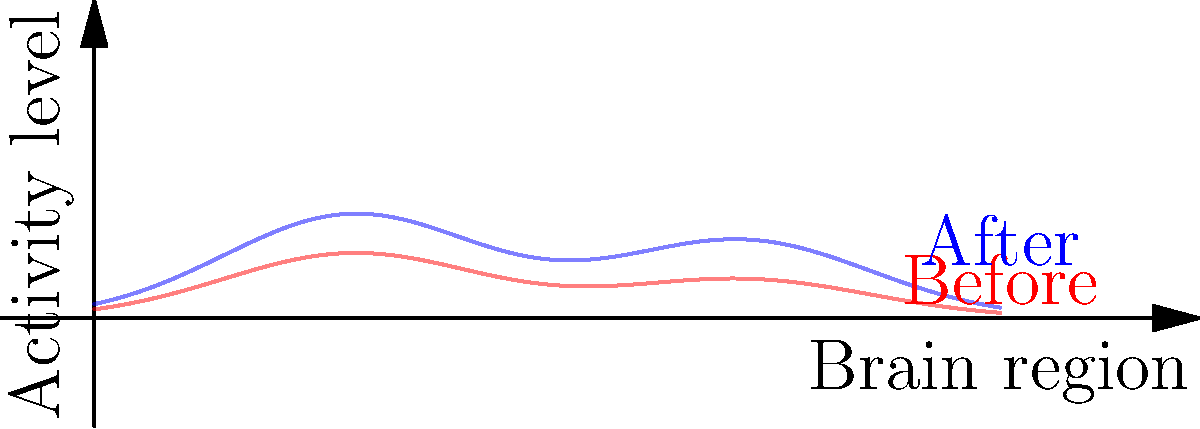Based on the heat map representation of brain activity patterns before and after a cognitive enhancement intervention, what potential concern might a neurologist raise regarding the observed changes? To answer this question, let's analyze the heat map step-by-step:

1. The red curve represents brain activity before the cognitive enhancement intervention, while the blue curve represents activity after the intervention.

2. We can observe that the blue curve shows higher peaks and overall increased activity compared to the red curve across all brain regions.

3. The increase in activity is not uniform:
   a. The first peak (around x=2) shows a more substantial increase.
   b. The second peak (around x=5) also increases but to a lesser extent.

4. From a neurologist's perspective, especially one who questions the safety and efficacy of cognitive enhancement methods, several concerns might arise:

   a. Overactivation: The significant increase in brain activity might lead to overactivation of certain brain regions, potentially causing neurological side effects or exhaustion.
   
   b. Imbalance: The non-uniform increase in activity across different brain regions might disrupt the brain's natural balance, potentially affecting other cognitive functions not intended to be enhanced.
   
   c. Long-term effects: Without substantial scientific evidence, it's unclear how this increased activity might affect the brain over time. There could be concerns about neural plasticity, neurotransmitter depletion, or even potential damage from prolonged overactivation.
   
   d. Lack of specificity: The enhancement appears to affect multiple brain regions, which might indicate a lack of specificity in the intervention. This could lead to unintended cognitive or behavioral changes.

5. Given the persona of a neurologist who questions the safety and efficacy of cognitive enhancement methods without substantial scientific evidence, the most pressing concern would likely be the potential for overactivation and its unknown long-term consequences.
Answer: Potential overactivation and unknown long-term effects 